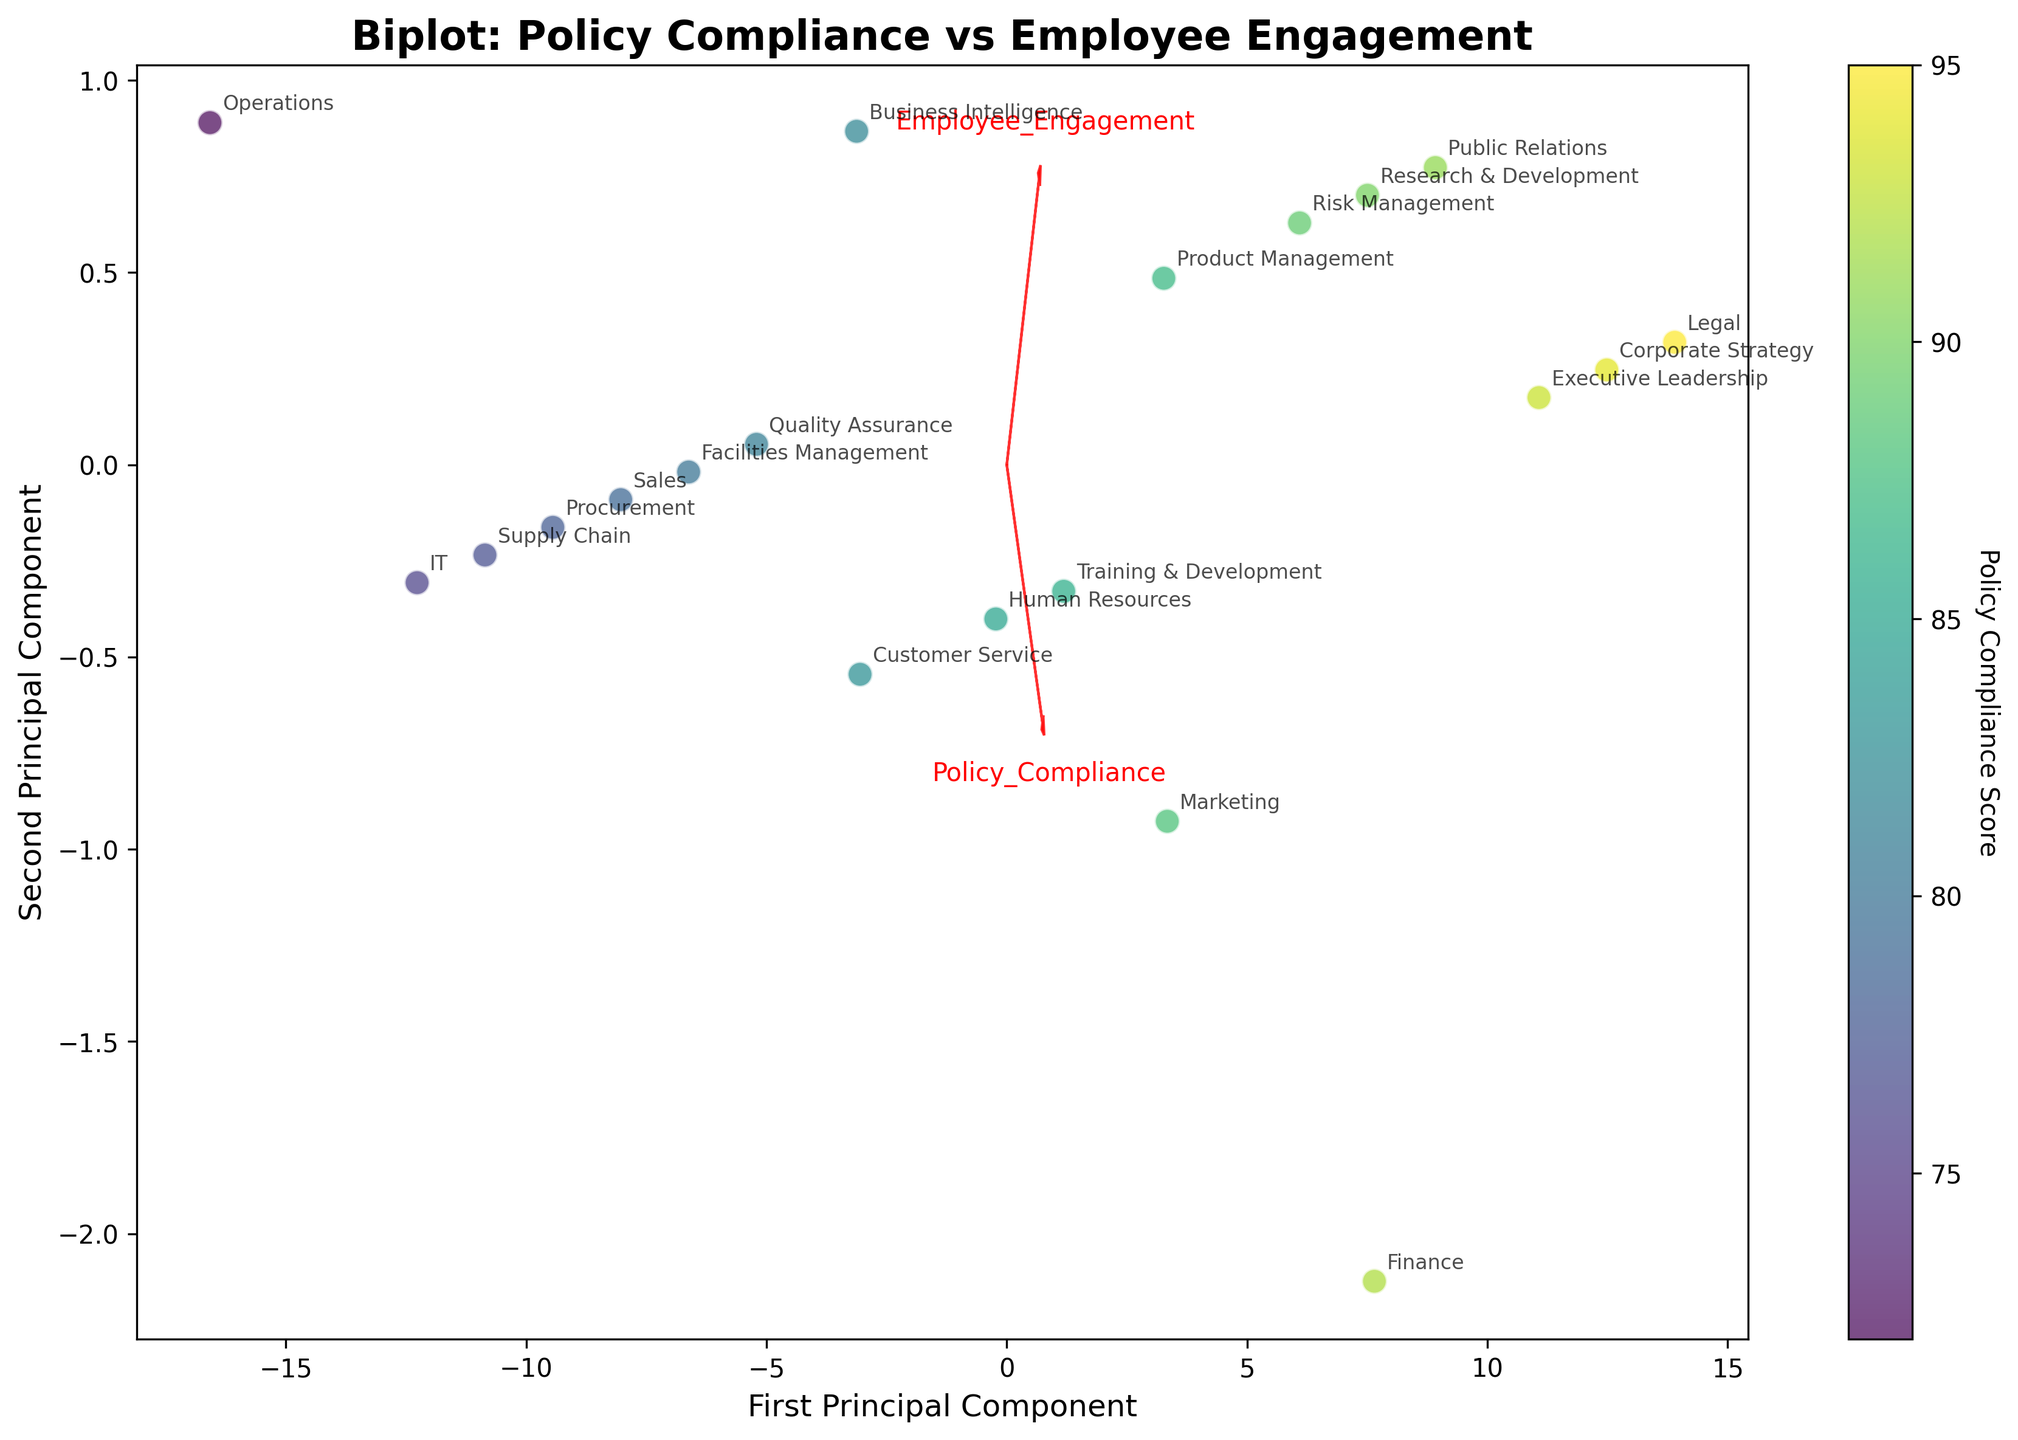How many departments are represented in the plot? By counting the unique data points (names of departments) shown on the plot, 20 departments can be identified.
Answer: 20 What do the arrows in the plot indicate? The arrows in the biplot represent the direction and magnitude of the original variables (Policy_Compliance and Employee_Engagement) in the principal component space.
Answer: Directions and magnitudes of original variables Which department has the highest Policy Compliance score? The colorbar indicates Policy Compliance scores, and the dot with the highest color value corresponds to the Legal department.
Answer: Legal Which principal component is more influenced by Policy Compliance? Comparing the component vectors, the arrow for Policy Compliance is longer along the First Principal Component, indicating stronger influence.
Answer: First Principal Component Compare the Employee Engagement scores for the Marketing and IT departments. Which has a higher score? By observing the placement of Marketing and IT on the plot, Marketing has a higher Employee Engagement score (80 vs 70).
Answer: Marketing Is there a strong relationship between Policy Compliance and Employee Engagement? The close grouping of points and similar directions of the arrows suggest a strong positive relationship between the two variables.
Answer: Yes Which department's data point is closest to the origin (0,0) in the transformed PCA space? By looking at the plot for the point nearest to the origin in the transformed PCA space, the Operations department is closest.
Answer: Operations How do the Research & Development and the Sales departments compare in terms of Policy Compliance? The plot shows that Research & Development has a higher Policy Compliance score compared to Sales.
Answer: Research & Development Which two departments have the most similar Policy Compliance and Employee Engagement scores? Data points for departments closest together with similar colors are Marketing and Product Management.
Answer: Marketing and Product Management What does the color of the data points signify? The color scale from the colorbar represents the Policy Compliance scores, with lighter colors indicating higher compliance.
Answer: Policy Compliance scores 